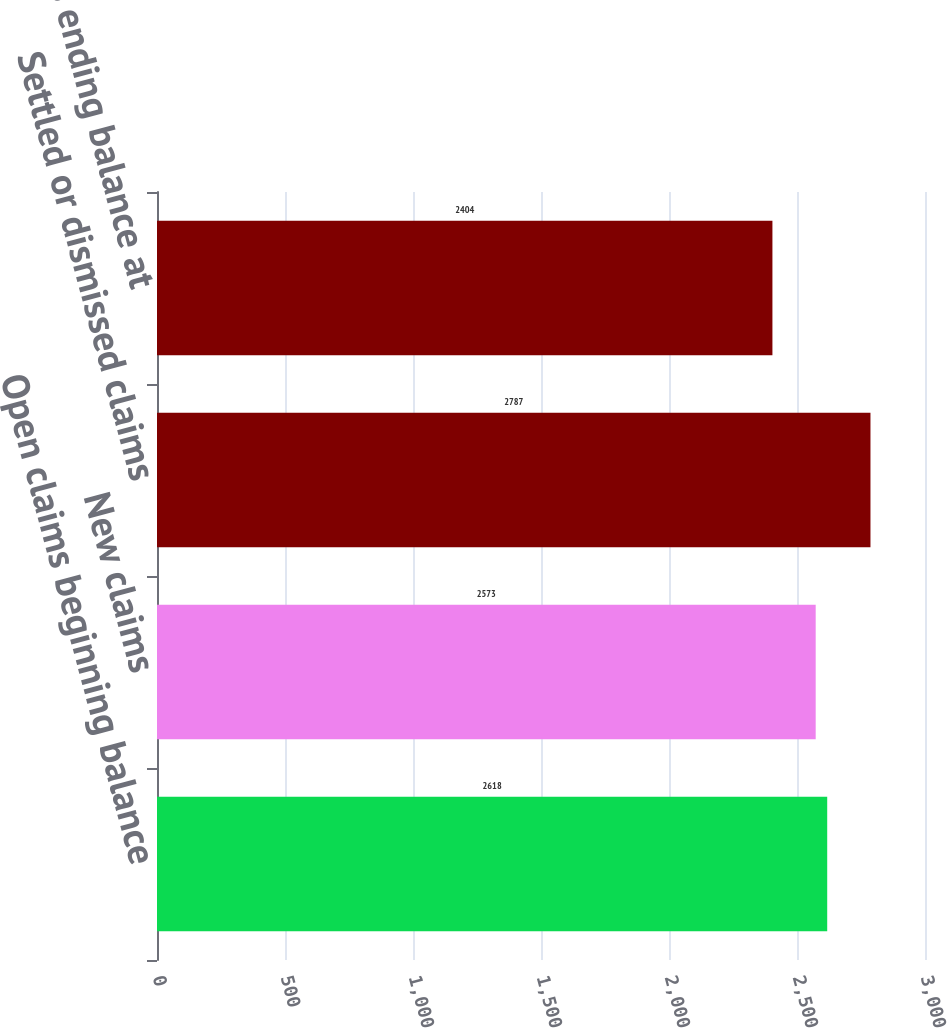Convert chart. <chart><loc_0><loc_0><loc_500><loc_500><bar_chart><fcel>Open claims beginning balance<fcel>New claims<fcel>Settled or dismissed claims<fcel>Open claims ending balance at<nl><fcel>2618<fcel>2573<fcel>2787<fcel>2404<nl></chart> 